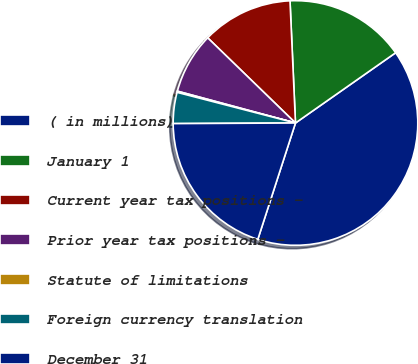<chart> <loc_0><loc_0><loc_500><loc_500><pie_chart><fcel>( in millions)<fcel>January 1<fcel>Current year tax positions -<fcel>Prior year tax positions -<fcel>Statute of limitations<fcel>Foreign currency translation<fcel>December 31<nl><fcel>39.72%<fcel>15.98%<fcel>12.03%<fcel>8.07%<fcel>0.16%<fcel>4.11%<fcel>19.94%<nl></chart> 